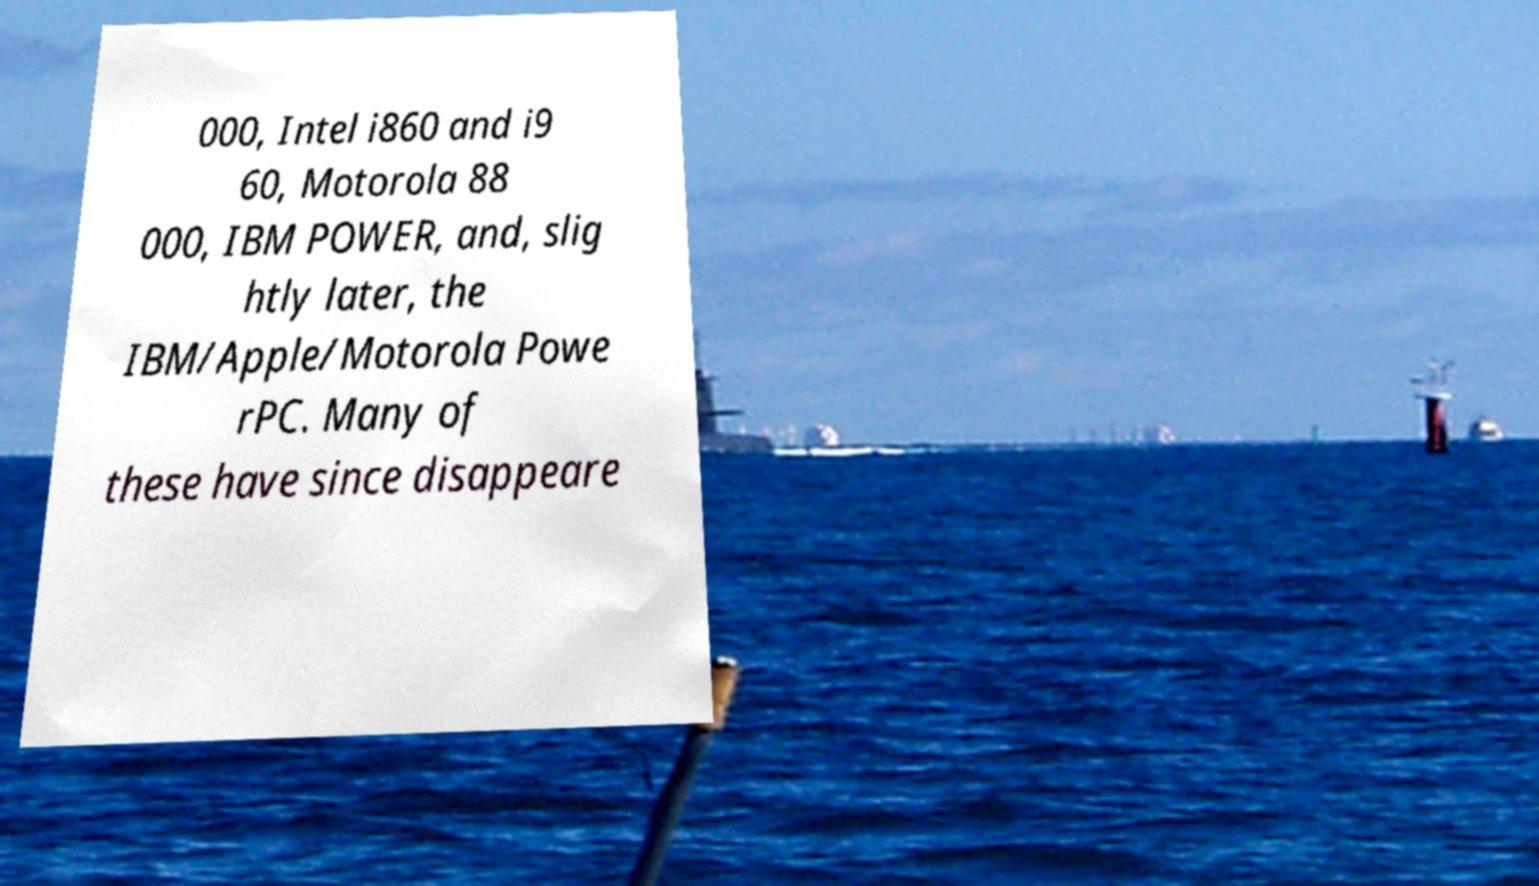What messages or text are displayed in this image? I need them in a readable, typed format. 000, Intel i860 and i9 60, Motorola 88 000, IBM POWER, and, slig htly later, the IBM/Apple/Motorola Powe rPC. Many of these have since disappeare 